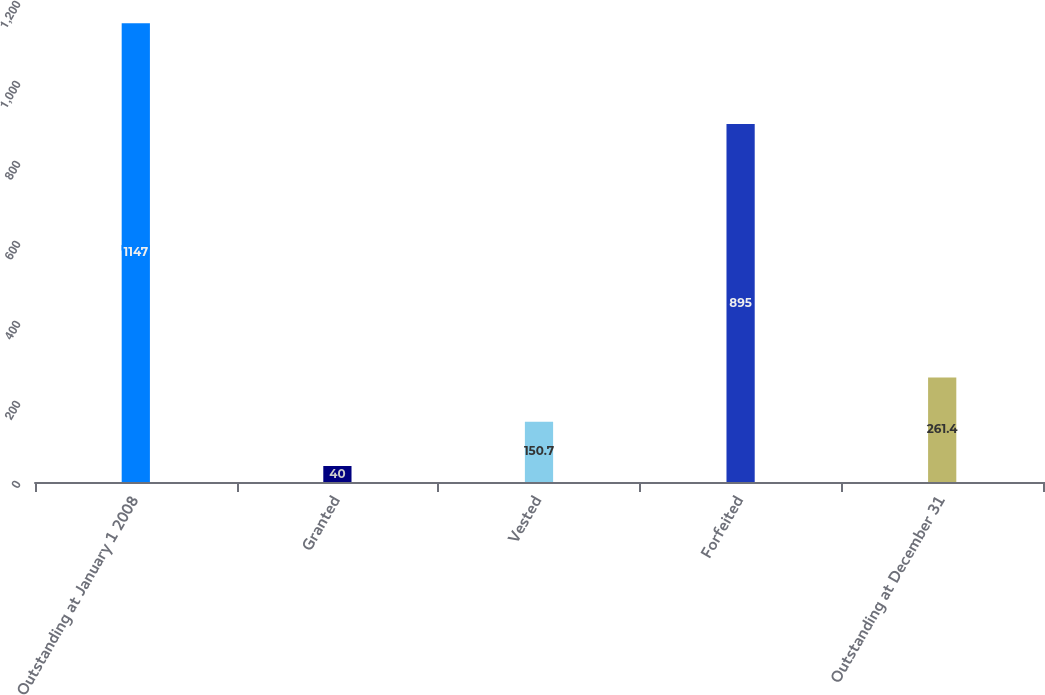Convert chart. <chart><loc_0><loc_0><loc_500><loc_500><bar_chart><fcel>Outstanding at January 1 2008<fcel>Granted<fcel>Vested<fcel>Forfeited<fcel>Outstanding at December 31<nl><fcel>1147<fcel>40<fcel>150.7<fcel>895<fcel>261.4<nl></chart> 